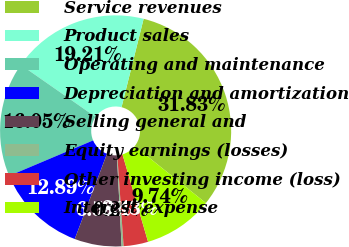Convert chart to OTSL. <chart><loc_0><loc_0><loc_500><loc_500><pie_chart><fcel>Service revenues<fcel>Product sales<fcel>Operating and maintenance<fcel>Depreciation and amortization<fcel>Selling general and<fcel>Equity earnings (losses)<fcel>Other investing income (loss)<fcel>Interest expense<nl><fcel>31.83%<fcel>19.21%<fcel>16.05%<fcel>12.89%<fcel>6.58%<fcel>0.27%<fcel>3.43%<fcel>9.74%<nl></chart> 